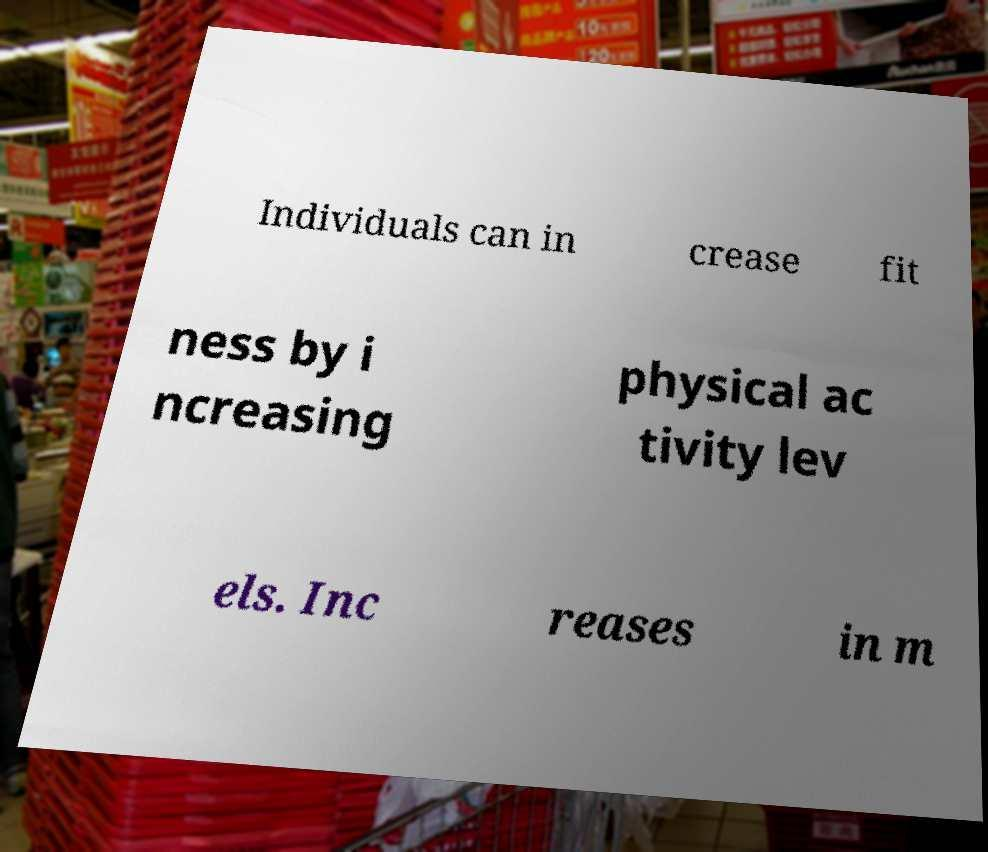What messages or text are displayed in this image? I need them in a readable, typed format. Individuals can in crease fit ness by i ncreasing physical ac tivity lev els. Inc reases in m 